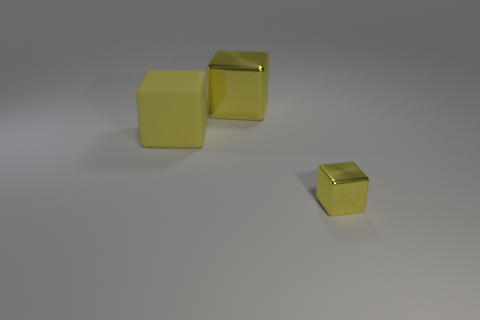What number of yellow metal blocks are behind the big yellow rubber object?
Offer a very short reply. 1. Does the large rubber object have the same color as the small metallic object?
Provide a succinct answer. Yes. Is the shape of the yellow thing that is in front of the big matte object the same as  the big yellow rubber object?
Give a very brief answer. Yes. What number of yellow things are either large metallic cubes or tiny blocks?
Offer a very short reply. 2. Is the number of large metal objects that are in front of the big metal cube the same as the number of small yellow cubes on the left side of the large yellow matte object?
Provide a short and direct response. Yes. The big shiny block on the right side of the yellow object left of the yellow metal cube that is behind the yellow matte block is what color?
Your answer should be compact. Yellow. What is the shape of the small object that is the same color as the big rubber object?
Provide a succinct answer. Cube. What is the size of the thing in front of the rubber block?
Ensure brevity in your answer.  Small. What shape is the metallic object that is the same size as the matte thing?
Your answer should be compact. Cube. Are the cube that is in front of the large yellow matte object and the large thing on the left side of the big metal cube made of the same material?
Your answer should be very brief. No. 